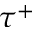<formula> <loc_0><loc_0><loc_500><loc_500>\tau ^ { + }</formula> 